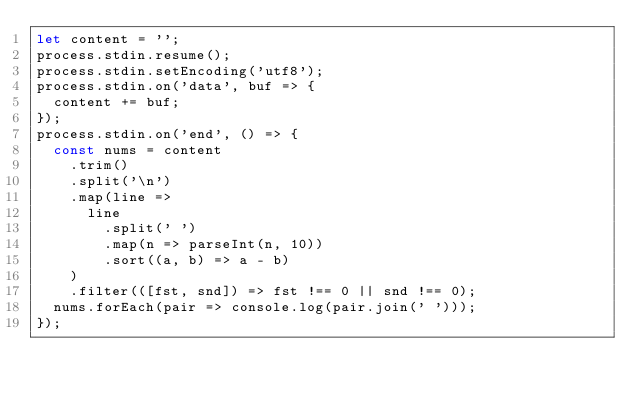Convert code to text. <code><loc_0><loc_0><loc_500><loc_500><_JavaScript_>let content = '';
process.stdin.resume();
process.stdin.setEncoding('utf8');
process.stdin.on('data', buf => {
  content += buf;
});
process.stdin.on('end', () => {
  const nums = content
    .trim()
    .split('\n')
    .map(line =>
      line
        .split(' ')
        .map(n => parseInt(n, 10))
        .sort((a, b) => a - b)
    )
    .filter(([fst, snd]) => fst !== 0 || snd !== 0);
  nums.forEach(pair => console.log(pair.join(' ')));
});
</code> 